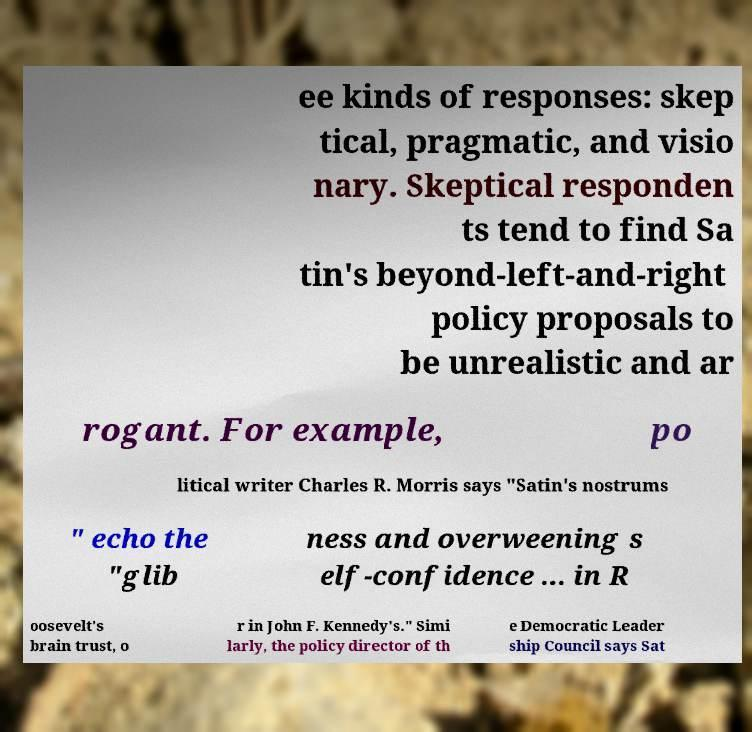There's text embedded in this image that I need extracted. Can you transcribe it verbatim? ee kinds of responses: skep tical, pragmatic, and visio nary. Skeptical responden ts tend to find Sa tin's beyond-left-and-right policy proposals to be unrealistic and ar rogant. For example, po litical writer Charles R. Morris says "Satin's nostrums " echo the "glib ness and overweening s elf-confidence ... in R oosevelt's brain trust, o r in John F. Kennedy's." Simi larly, the policy director of th e Democratic Leader ship Council says Sat 